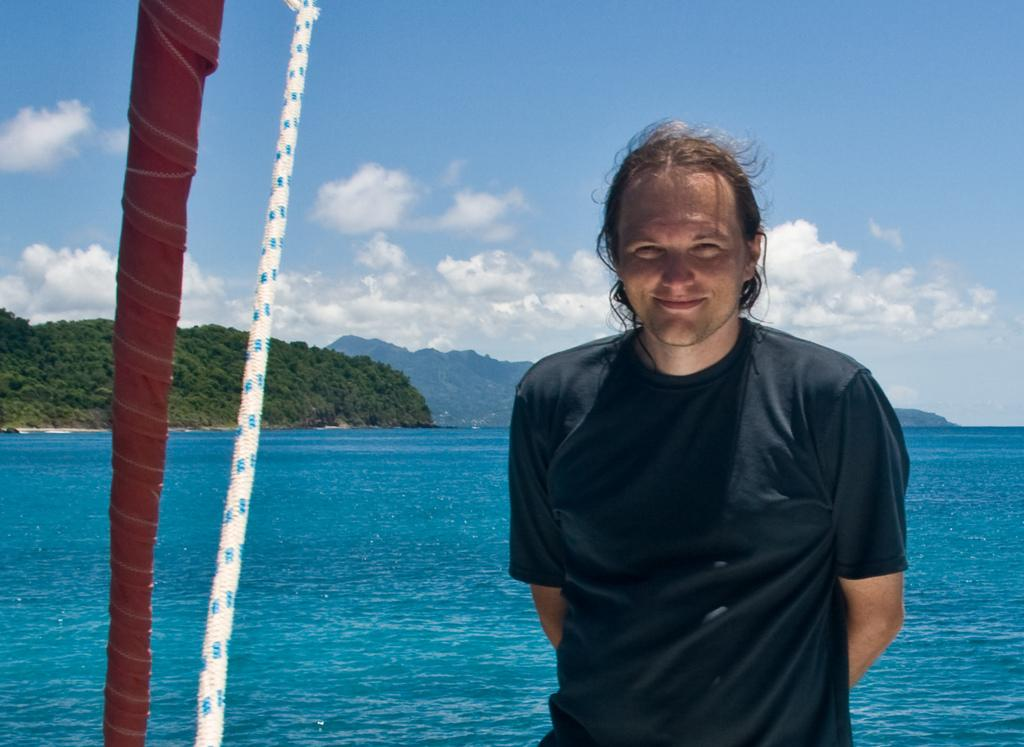What object can be seen in the image that is made of fabric? There is a cloth in the image. What other object can be seen in the image that is not made of fabric? There is a rope in the image. What is the man in the image doing? The man is standing and smiling in the image. What type of natural environment is visible in the image? There are trees, water, mountains, and sky visible in the image. What is the condition of the sky in the image? The sky is visible in the background of the image, and clouds are present. What type of building can be seen in the image? There is no building present in the image; it features a man standing and smiling, a cloth, a rope, trees, water, mountains, and a sky with clouds. 